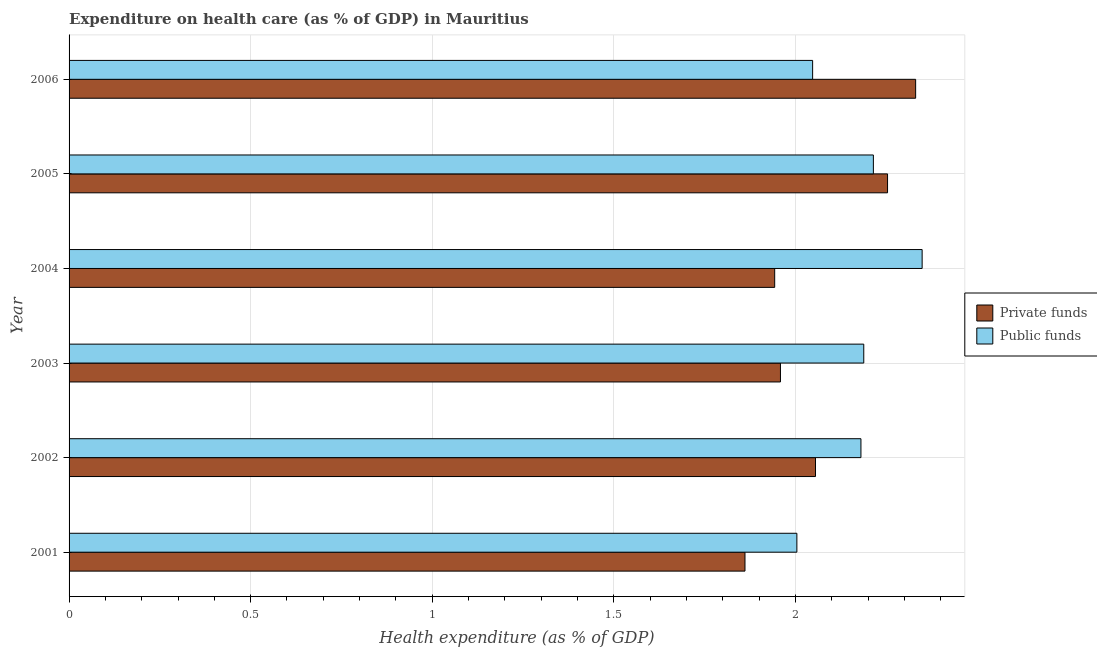How many different coloured bars are there?
Your answer should be compact. 2. Are the number of bars on each tick of the Y-axis equal?
Ensure brevity in your answer.  Yes. How many bars are there on the 6th tick from the top?
Your answer should be compact. 2. How many bars are there on the 4th tick from the bottom?
Ensure brevity in your answer.  2. In how many cases, is the number of bars for a given year not equal to the number of legend labels?
Offer a terse response. 0. What is the amount of public funds spent in healthcare in 2002?
Your response must be concise. 2.18. Across all years, what is the maximum amount of public funds spent in healthcare?
Keep it short and to the point. 2.35. Across all years, what is the minimum amount of private funds spent in healthcare?
Offer a terse response. 1.86. In which year was the amount of private funds spent in healthcare maximum?
Provide a short and direct response. 2006. What is the total amount of public funds spent in healthcare in the graph?
Offer a terse response. 12.98. What is the difference between the amount of public funds spent in healthcare in 2001 and that in 2004?
Provide a succinct answer. -0.34. What is the difference between the amount of public funds spent in healthcare in 2001 and the amount of private funds spent in healthcare in 2005?
Your answer should be compact. -0.25. What is the average amount of private funds spent in healthcare per year?
Provide a short and direct response. 2.07. In the year 2003, what is the difference between the amount of private funds spent in healthcare and amount of public funds spent in healthcare?
Keep it short and to the point. -0.23. What is the ratio of the amount of public funds spent in healthcare in 2004 to that in 2005?
Offer a very short reply. 1.06. What is the difference between the highest and the second highest amount of public funds spent in healthcare?
Offer a very short reply. 0.13. What is the difference between the highest and the lowest amount of private funds spent in healthcare?
Your response must be concise. 0.47. Is the sum of the amount of public funds spent in healthcare in 2005 and 2006 greater than the maximum amount of private funds spent in healthcare across all years?
Keep it short and to the point. Yes. What does the 2nd bar from the top in 2002 represents?
Keep it short and to the point. Private funds. What does the 2nd bar from the bottom in 2006 represents?
Your answer should be very brief. Public funds. How many years are there in the graph?
Offer a terse response. 6. What is the difference between two consecutive major ticks on the X-axis?
Provide a short and direct response. 0.5. Does the graph contain any zero values?
Your response must be concise. No. How many legend labels are there?
Keep it short and to the point. 2. How are the legend labels stacked?
Offer a terse response. Vertical. What is the title of the graph?
Give a very brief answer. Expenditure on health care (as % of GDP) in Mauritius. What is the label or title of the X-axis?
Provide a short and direct response. Health expenditure (as % of GDP). What is the label or title of the Y-axis?
Ensure brevity in your answer.  Year. What is the Health expenditure (as % of GDP) in Private funds in 2001?
Offer a very short reply. 1.86. What is the Health expenditure (as % of GDP) of Public funds in 2001?
Your response must be concise. 2. What is the Health expenditure (as % of GDP) in Private funds in 2002?
Give a very brief answer. 2.06. What is the Health expenditure (as % of GDP) of Public funds in 2002?
Offer a very short reply. 2.18. What is the Health expenditure (as % of GDP) of Private funds in 2003?
Give a very brief answer. 1.96. What is the Health expenditure (as % of GDP) of Public funds in 2003?
Ensure brevity in your answer.  2.19. What is the Health expenditure (as % of GDP) of Private funds in 2004?
Provide a short and direct response. 1.94. What is the Health expenditure (as % of GDP) of Public funds in 2004?
Ensure brevity in your answer.  2.35. What is the Health expenditure (as % of GDP) of Private funds in 2005?
Offer a terse response. 2.25. What is the Health expenditure (as % of GDP) of Public funds in 2005?
Make the answer very short. 2.21. What is the Health expenditure (as % of GDP) of Private funds in 2006?
Keep it short and to the point. 2.33. What is the Health expenditure (as % of GDP) in Public funds in 2006?
Ensure brevity in your answer.  2.05. Across all years, what is the maximum Health expenditure (as % of GDP) of Private funds?
Offer a very short reply. 2.33. Across all years, what is the maximum Health expenditure (as % of GDP) in Public funds?
Give a very brief answer. 2.35. Across all years, what is the minimum Health expenditure (as % of GDP) of Private funds?
Offer a very short reply. 1.86. Across all years, what is the minimum Health expenditure (as % of GDP) of Public funds?
Make the answer very short. 2. What is the total Health expenditure (as % of GDP) of Private funds in the graph?
Offer a very short reply. 12.4. What is the total Health expenditure (as % of GDP) of Public funds in the graph?
Your answer should be very brief. 12.98. What is the difference between the Health expenditure (as % of GDP) of Private funds in 2001 and that in 2002?
Your answer should be very brief. -0.19. What is the difference between the Health expenditure (as % of GDP) in Public funds in 2001 and that in 2002?
Your answer should be very brief. -0.18. What is the difference between the Health expenditure (as % of GDP) in Private funds in 2001 and that in 2003?
Provide a short and direct response. -0.1. What is the difference between the Health expenditure (as % of GDP) of Public funds in 2001 and that in 2003?
Provide a short and direct response. -0.18. What is the difference between the Health expenditure (as % of GDP) of Private funds in 2001 and that in 2004?
Offer a terse response. -0.08. What is the difference between the Health expenditure (as % of GDP) in Public funds in 2001 and that in 2004?
Provide a short and direct response. -0.34. What is the difference between the Health expenditure (as % of GDP) in Private funds in 2001 and that in 2005?
Provide a short and direct response. -0.39. What is the difference between the Health expenditure (as % of GDP) in Public funds in 2001 and that in 2005?
Your answer should be very brief. -0.21. What is the difference between the Health expenditure (as % of GDP) in Private funds in 2001 and that in 2006?
Your response must be concise. -0.47. What is the difference between the Health expenditure (as % of GDP) in Public funds in 2001 and that in 2006?
Ensure brevity in your answer.  -0.04. What is the difference between the Health expenditure (as % of GDP) of Private funds in 2002 and that in 2003?
Provide a short and direct response. 0.1. What is the difference between the Health expenditure (as % of GDP) in Public funds in 2002 and that in 2003?
Offer a terse response. -0.01. What is the difference between the Health expenditure (as % of GDP) in Private funds in 2002 and that in 2004?
Provide a succinct answer. 0.11. What is the difference between the Health expenditure (as % of GDP) in Public funds in 2002 and that in 2004?
Offer a terse response. -0.17. What is the difference between the Health expenditure (as % of GDP) in Private funds in 2002 and that in 2005?
Your answer should be compact. -0.2. What is the difference between the Health expenditure (as % of GDP) in Public funds in 2002 and that in 2005?
Give a very brief answer. -0.03. What is the difference between the Health expenditure (as % of GDP) of Private funds in 2002 and that in 2006?
Give a very brief answer. -0.28. What is the difference between the Health expenditure (as % of GDP) in Public funds in 2002 and that in 2006?
Keep it short and to the point. 0.13. What is the difference between the Health expenditure (as % of GDP) of Private funds in 2003 and that in 2004?
Ensure brevity in your answer.  0.02. What is the difference between the Health expenditure (as % of GDP) in Public funds in 2003 and that in 2004?
Make the answer very short. -0.16. What is the difference between the Health expenditure (as % of GDP) of Private funds in 2003 and that in 2005?
Your answer should be very brief. -0.29. What is the difference between the Health expenditure (as % of GDP) in Public funds in 2003 and that in 2005?
Make the answer very short. -0.03. What is the difference between the Health expenditure (as % of GDP) of Private funds in 2003 and that in 2006?
Keep it short and to the point. -0.37. What is the difference between the Health expenditure (as % of GDP) in Public funds in 2003 and that in 2006?
Keep it short and to the point. 0.14. What is the difference between the Health expenditure (as % of GDP) of Private funds in 2004 and that in 2005?
Make the answer very short. -0.31. What is the difference between the Health expenditure (as % of GDP) of Public funds in 2004 and that in 2005?
Your answer should be compact. 0.13. What is the difference between the Health expenditure (as % of GDP) of Private funds in 2004 and that in 2006?
Your answer should be compact. -0.39. What is the difference between the Health expenditure (as % of GDP) in Public funds in 2004 and that in 2006?
Offer a very short reply. 0.3. What is the difference between the Health expenditure (as % of GDP) of Private funds in 2005 and that in 2006?
Your response must be concise. -0.08. What is the difference between the Health expenditure (as % of GDP) in Public funds in 2005 and that in 2006?
Your answer should be very brief. 0.17. What is the difference between the Health expenditure (as % of GDP) in Private funds in 2001 and the Health expenditure (as % of GDP) in Public funds in 2002?
Your answer should be compact. -0.32. What is the difference between the Health expenditure (as % of GDP) of Private funds in 2001 and the Health expenditure (as % of GDP) of Public funds in 2003?
Ensure brevity in your answer.  -0.33. What is the difference between the Health expenditure (as % of GDP) in Private funds in 2001 and the Health expenditure (as % of GDP) in Public funds in 2004?
Your answer should be compact. -0.49. What is the difference between the Health expenditure (as % of GDP) in Private funds in 2001 and the Health expenditure (as % of GDP) in Public funds in 2005?
Keep it short and to the point. -0.35. What is the difference between the Health expenditure (as % of GDP) of Private funds in 2001 and the Health expenditure (as % of GDP) of Public funds in 2006?
Your response must be concise. -0.19. What is the difference between the Health expenditure (as % of GDP) in Private funds in 2002 and the Health expenditure (as % of GDP) in Public funds in 2003?
Provide a short and direct response. -0.13. What is the difference between the Health expenditure (as % of GDP) of Private funds in 2002 and the Health expenditure (as % of GDP) of Public funds in 2004?
Give a very brief answer. -0.29. What is the difference between the Health expenditure (as % of GDP) in Private funds in 2002 and the Health expenditure (as % of GDP) in Public funds in 2005?
Provide a succinct answer. -0.16. What is the difference between the Health expenditure (as % of GDP) of Private funds in 2002 and the Health expenditure (as % of GDP) of Public funds in 2006?
Provide a short and direct response. 0.01. What is the difference between the Health expenditure (as % of GDP) of Private funds in 2003 and the Health expenditure (as % of GDP) of Public funds in 2004?
Offer a terse response. -0.39. What is the difference between the Health expenditure (as % of GDP) in Private funds in 2003 and the Health expenditure (as % of GDP) in Public funds in 2005?
Provide a succinct answer. -0.26. What is the difference between the Health expenditure (as % of GDP) of Private funds in 2003 and the Health expenditure (as % of GDP) of Public funds in 2006?
Make the answer very short. -0.09. What is the difference between the Health expenditure (as % of GDP) of Private funds in 2004 and the Health expenditure (as % of GDP) of Public funds in 2005?
Make the answer very short. -0.27. What is the difference between the Health expenditure (as % of GDP) of Private funds in 2004 and the Health expenditure (as % of GDP) of Public funds in 2006?
Your answer should be very brief. -0.1. What is the difference between the Health expenditure (as % of GDP) in Private funds in 2005 and the Health expenditure (as % of GDP) in Public funds in 2006?
Provide a short and direct response. 0.21. What is the average Health expenditure (as % of GDP) of Private funds per year?
Offer a terse response. 2.07. What is the average Health expenditure (as % of GDP) of Public funds per year?
Your answer should be compact. 2.16. In the year 2001, what is the difference between the Health expenditure (as % of GDP) in Private funds and Health expenditure (as % of GDP) in Public funds?
Offer a terse response. -0.14. In the year 2002, what is the difference between the Health expenditure (as % of GDP) in Private funds and Health expenditure (as % of GDP) in Public funds?
Your answer should be very brief. -0.13. In the year 2003, what is the difference between the Health expenditure (as % of GDP) in Private funds and Health expenditure (as % of GDP) in Public funds?
Give a very brief answer. -0.23. In the year 2004, what is the difference between the Health expenditure (as % of GDP) in Private funds and Health expenditure (as % of GDP) in Public funds?
Give a very brief answer. -0.41. In the year 2005, what is the difference between the Health expenditure (as % of GDP) in Private funds and Health expenditure (as % of GDP) in Public funds?
Provide a succinct answer. 0.04. In the year 2006, what is the difference between the Health expenditure (as % of GDP) in Private funds and Health expenditure (as % of GDP) in Public funds?
Your answer should be very brief. 0.28. What is the ratio of the Health expenditure (as % of GDP) in Private funds in 2001 to that in 2002?
Your response must be concise. 0.91. What is the ratio of the Health expenditure (as % of GDP) in Public funds in 2001 to that in 2002?
Keep it short and to the point. 0.92. What is the ratio of the Health expenditure (as % of GDP) in Private funds in 2001 to that in 2003?
Your answer should be very brief. 0.95. What is the ratio of the Health expenditure (as % of GDP) in Public funds in 2001 to that in 2003?
Your answer should be very brief. 0.92. What is the ratio of the Health expenditure (as % of GDP) of Private funds in 2001 to that in 2004?
Provide a succinct answer. 0.96. What is the ratio of the Health expenditure (as % of GDP) in Public funds in 2001 to that in 2004?
Make the answer very short. 0.85. What is the ratio of the Health expenditure (as % of GDP) of Private funds in 2001 to that in 2005?
Your response must be concise. 0.83. What is the ratio of the Health expenditure (as % of GDP) of Public funds in 2001 to that in 2005?
Your response must be concise. 0.9. What is the ratio of the Health expenditure (as % of GDP) in Private funds in 2001 to that in 2006?
Provide a succinct answer. 0.8. What is the ratio of the Health expenditure (as % of GDP) in Public funds in 2001 to that in 2006?
Make the answer very short. 0.98. What is the ratio of the Health expenditure (as % of GDP) in Private funds in 2002 to that in 2003?
Make the answer very short. 1.05. What is the ratio of the Health expenditure (as % of GDP) in Private funds in 2002 to that in 2004?
Make the answer very short. 1.06. What is the ratio of the Health expenditure (as % of GDP) in Public funds in 2002 to that in 2004?
Keep it short and to the point. 0.93. What is the ratio of the Health expenditure (as % of GDP) of Private funds in 2002 to that in 2005?
Keep it short and to the point. 0.91. What is the ratio of the Health expenditure (as % of GDP) in Public funds in 2002 to that in 2005?
Keep it short and to the point. 0.98. What is the ratio of the Health expenditure (as % of GDP) in Private funds in 2002 to that in 2006?
Your answer should be compact. 0.88. What is the ratio of the Health expenditure (as % of GDP) in Public funds in 2002 to that in 2006?
Provide a succinct answer. 1.06. What is the ratio of the Health expenditure (as % of GDP) in Private funds in 2003 to that in 2004?
Offer a very short reply. 1.01. What is the ratio of the Health expenditure (as % of GDP) in Public funds in 2003 to that in 2004?
Provide a succinct answer. 0.93. What is the ratio of the Health expenditure (as % of GDP) in Private funds in 2003 to that in 2005?
Offer a very short reply. 0.87. What is the ratio of the Health expenditure (as % of GDP) in Private funds in 2003 to that in 2006?
Give a very brief answer. 0.84. What is the ratio of the Health expenditure (as % of GDP) in Public funds in 2003 to that in 2006?
Provide a succinct answer. 1.07. What is the ratio of the Health expenditure (as % of GDP) in Private funds in 2004 to that in 2005?
Make the answer very short. 0.86. What is the ratio of the Health expenditure (as % of GDP) of Public funds in 2004 to that in 2005?
Give a very brief answer. 1.06. What is the ratio of the Health expenditure (as % of GDP) of Private funds in 2004 to that in 2006?
Offer a terse response. 0.83. What is the ratio of the Health expenditure (as % of GDP) in Public funds in 2004 to that in 2006?
Make the answer very short. 1.15. What is the ratio of the Health expenditure (as % of GDP) in Private funds in 2005 to that in 2006?
Make the answer very short. 0.97. What is the ratio of the Health expenditure (as % of GDP) of Public funds in 2005 to that in 2006?
Provide a short and direct response. 1.08. What is the difference between the highest and the second highest Health expenditure (as % of GDP) of Private funds?
Keep it short and to the point. 0.08. What is the difference between the highest and the second highest Health expenditure (as % of GDP) of Public funds?
Your answer should be compact. 0.13. What is the difference between the highest and the lowest Health expenditure (as % of GDP) in Private funds?
Keep it short and to the point. 0.47. What is the difference between the highest and the lowest Health expenditure (as % of GDP) in Public funds?
Your answer should be compact. 0.34. 